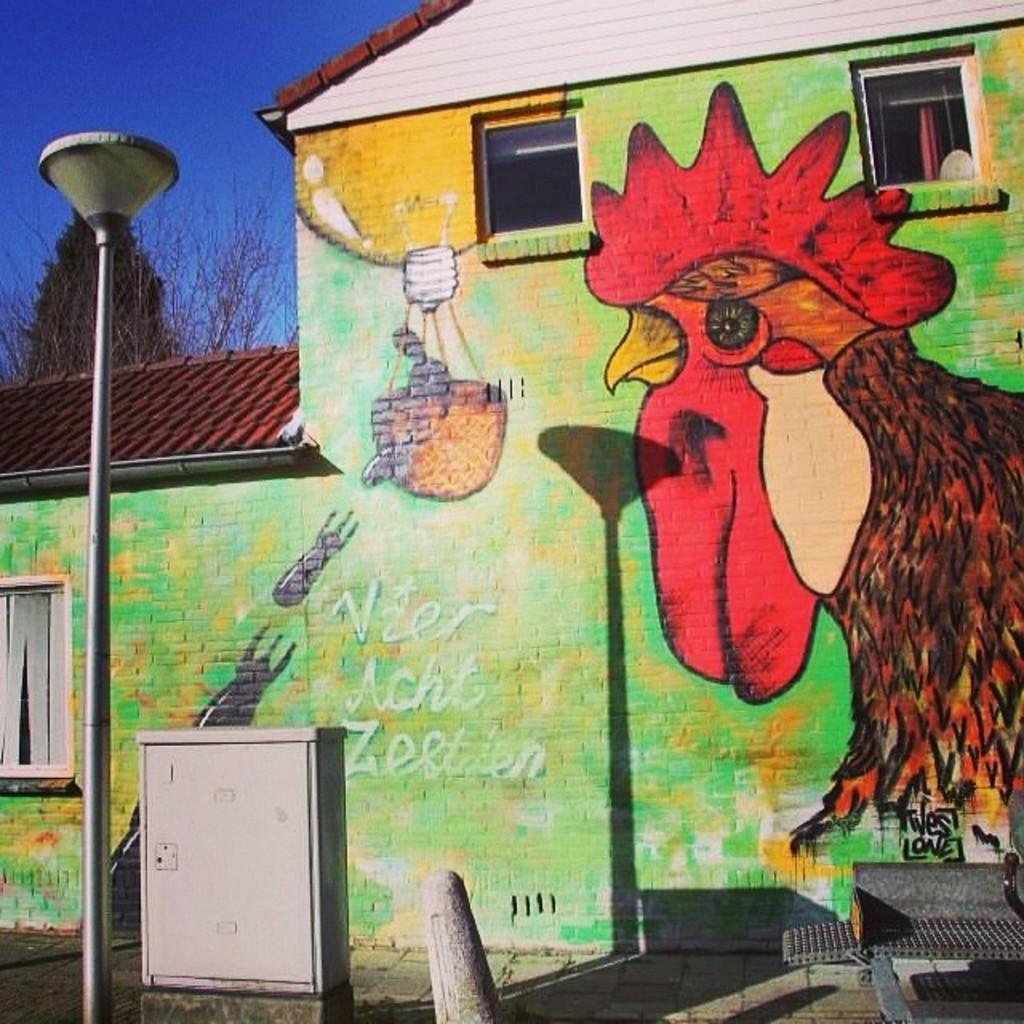Please provide a concise description of this image. In front of the image there is a light pole, electrical box, woolen pole and a chair. In the background of the image there is a painting on the wall. There are glass windows. There is a tree. At the top of the image there is sky. 